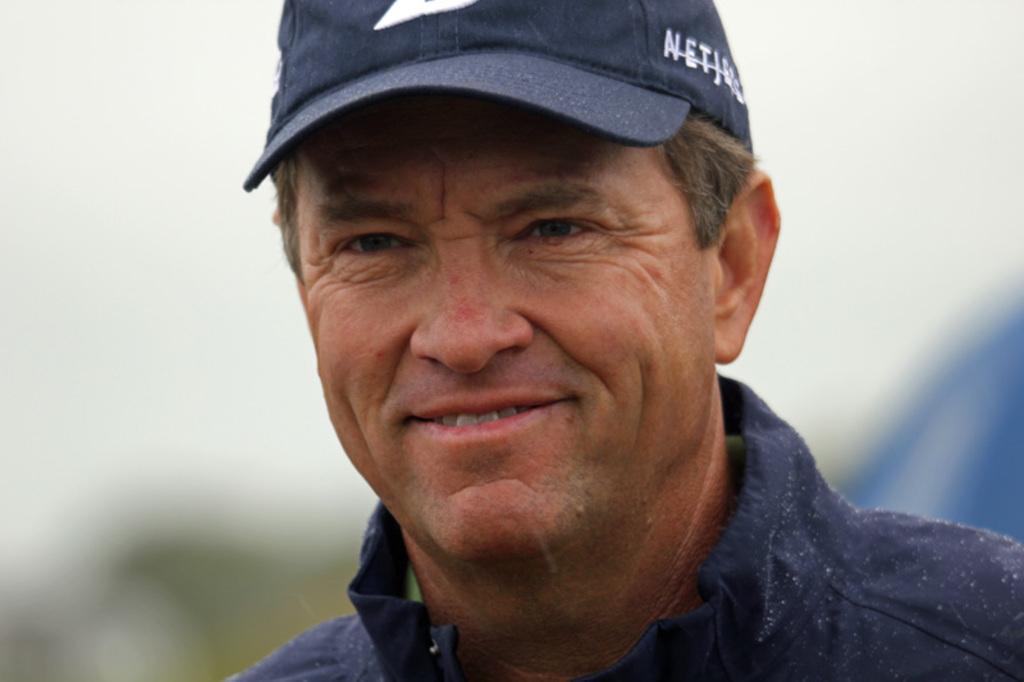Can you describe this image briefly? In this image I can see the person wearing the blue color dress and also cap. And there is blurred background. 